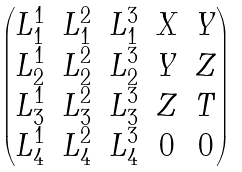<formula> <loc_0><loc_0><loc_500><loc_500>\begin{pmatrix} L _ { 1 } ^ { 1 } & L _ { 1 } ^ { 2 } & L _ { 1 } ^ { 3 } & X & Y \\ L _ { 2 } ^ { 1 } & L _ { 2 } ^ { 2 } & L _ { 2 } ^ { 3 } & Y & Z \\ L _ { 3 } ^ { 1 } & L _ { 3 } ^ { 2 } & L _ { 3 } ^ { 3 } & Z & T \\ L _ { 4 } ^ { 1 } & L _ { 4 } ^ { 2 } & L _ { 4 } ^ { 3 } & 0 & 0 \\ \end{pmatrix}</formula> 